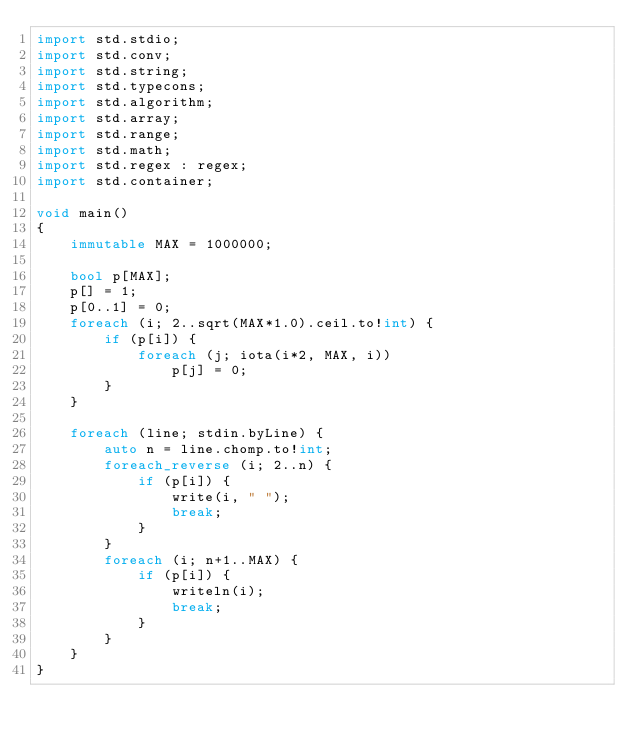<code> <loc_0><loc_0><loc_500><loc_500><_D_>import std.stdio;
import std.conv;
import std.string;
import std.typecons;
import std.algorithm;
import std.array;
import std.range;
import std.math;
import std.regex : regex;
import std.container;

void main()
{
	immutable MAX = 1000000;

	bool p[MAX];
	p[] = 1;
	p[0..1] = 0;
	foreach (i; 2..sqrt(MAX*1.0).ceil.to!int) {
		if (p[i]) {
			foreach (j; iota(i*2, MAX, i))
				p[j] = 0;
		}
	}

	foreach (line; stdin.byLine) {
		auto n = line.chomp.to!int;
		foreach_reverse (i; 2..n) {
			if (p[i]) {
				write(i, " ");
				break;
			}
		}
		foreach (i; n+1..MAX) {
			if (p[i]) {
				writeln(i);
				break;
			}
		}
	}
}</code> 